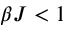Convert formula to latex. <formula><loc_0><loc_0><loc_500><loc_500>\beta J < 1</formula> 